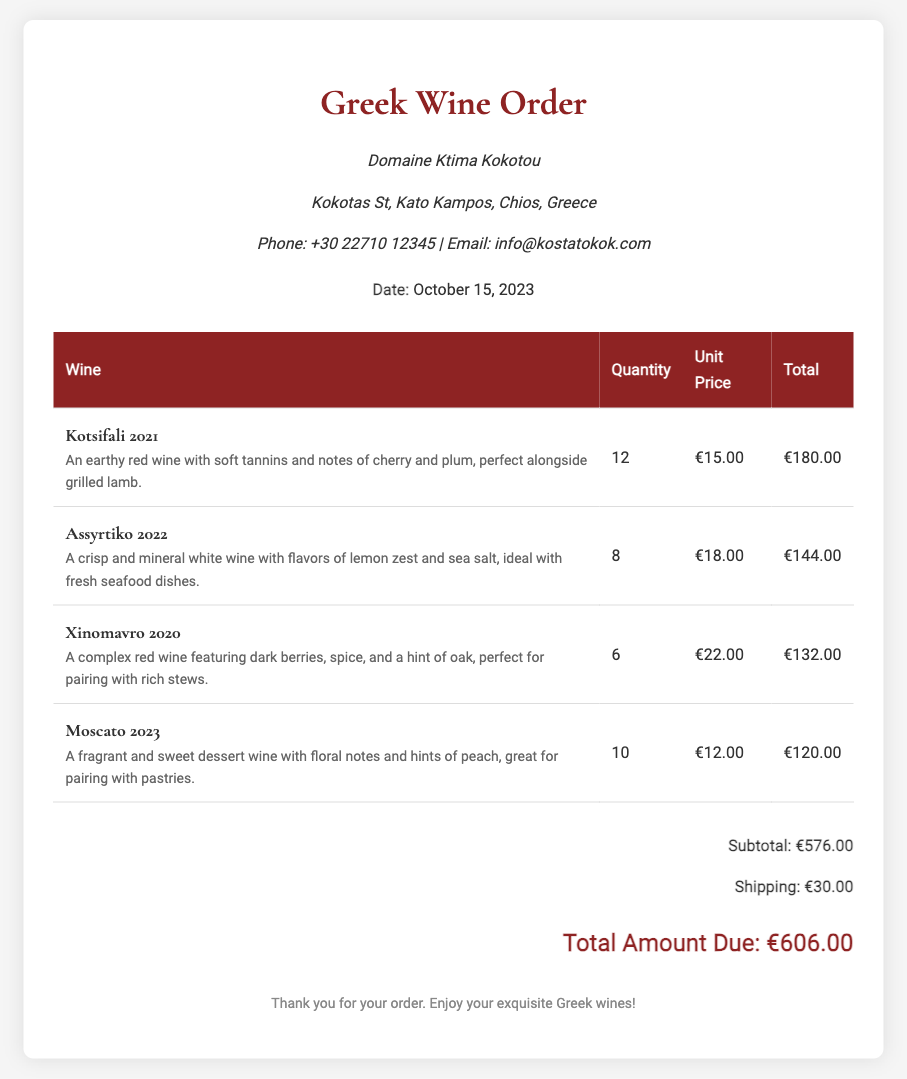What is the name of the winery? The name of the winery is mentioned in the header section of the document.
Answer: Domaine Ktima Kokotou What is the date of the order? The date of the order is provided in the header section of the document.
Answer: October 15, 2023 How many units of Kotsifali 2021 were ordered? The quantity of Kotsifali 2021 can be found in the corresponding row of the table.
Answer: 12 What is the unit price of Assyrtiko 2022? The unit price for Assyrtiko 2022 is listed in the table.
Answer: €18.00 What is the total amount due for the order? The total amount due is presented in the total section of the document.
Answer: €606.00 Which wine is described as "perfect for pairing with rich stews"? The description provided in the document indicates the best pairing for the Xinomavro 2020.
Answer: Xinomavro 2020 What is the subtotal for all wines ordered? The subtotal is calculated and displayed before shipping in the total section.
Answer: €576.00 How many Moscato 2023 were ordered? The quantity of Moscato 2023 is specified in the table.
Answer: 10 Which wine pairs well with grilled lamb? The document mentions specific wines that pair well with certain dishes.
Answer: Kotsifali 2021 